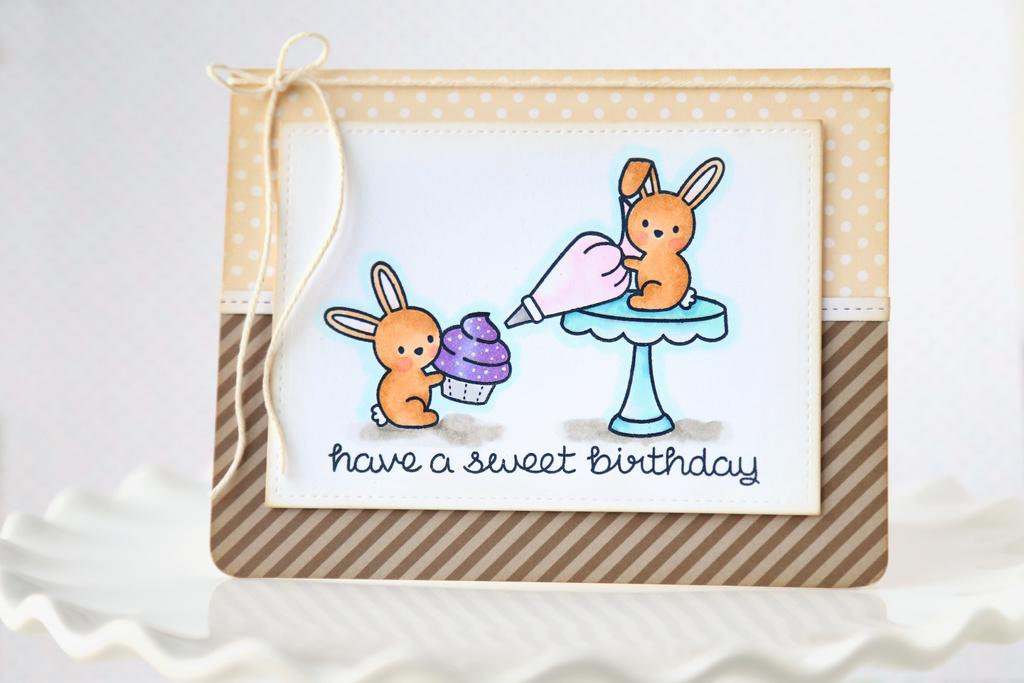What object is present on the plate in the image? There is a greeting card on the plate. What is written or depicted on the greeting card? There is text on the greeting card. Are there any additional elements on the greeting card? Yes, there are two toys on the greeting card. How are the toys positioned on the greeting card? The toys are tied with a thread. What type of owl can be seen causing a commotion in the image? There is no owl present in the image, nor is there any indication of a commotion. 